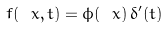Convert formula to latex. <formula><loc_0><loc_0><loc_500><loc_500>f ( \ x , t ) = \phi ( \ x ) \, \delta ^ { \prime } ( t ) \,</formula> 